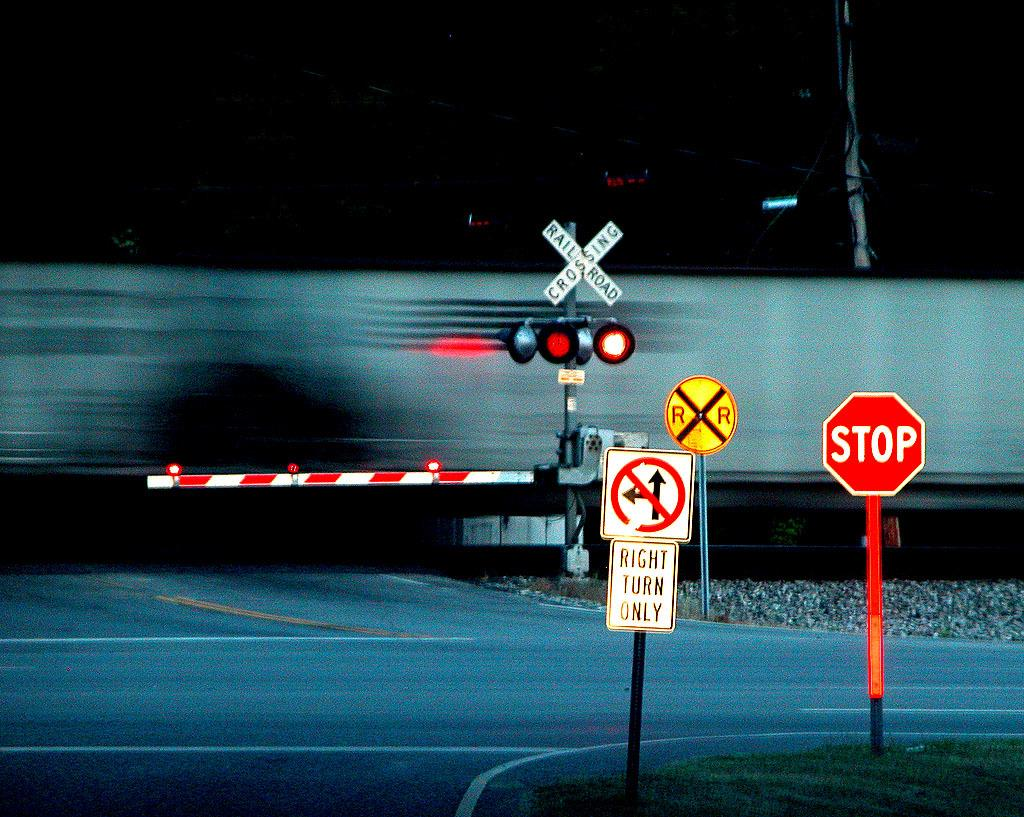<image>
Give a short and clear explanation of the subsequent image. A rail road intersection with a stop sign. 